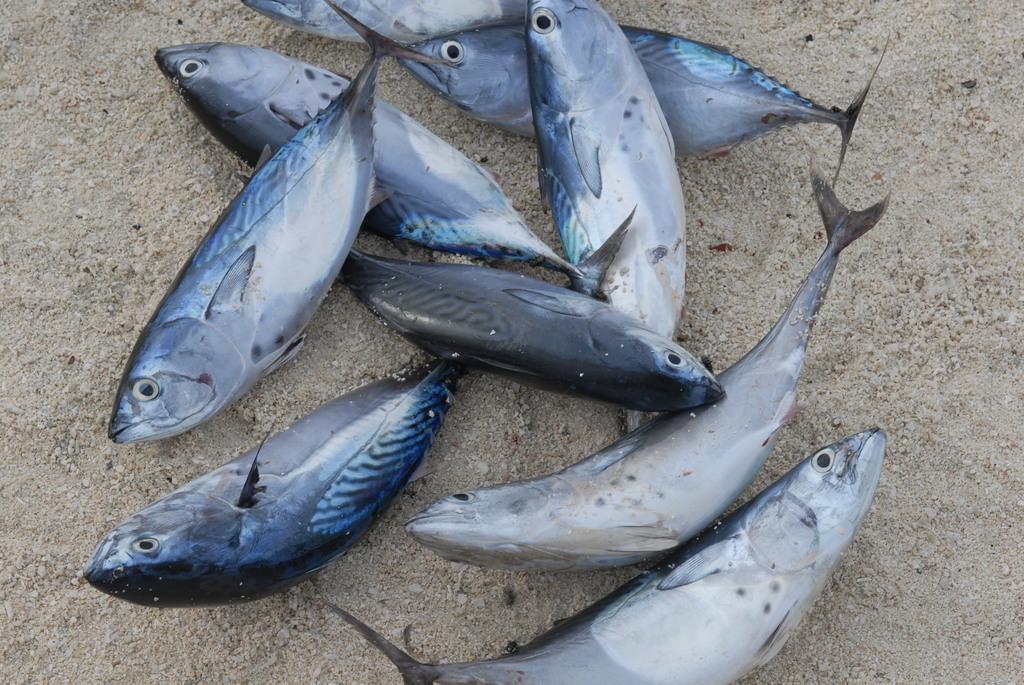Describe this image in one or two sentences. In this image few fishes are on the land. 